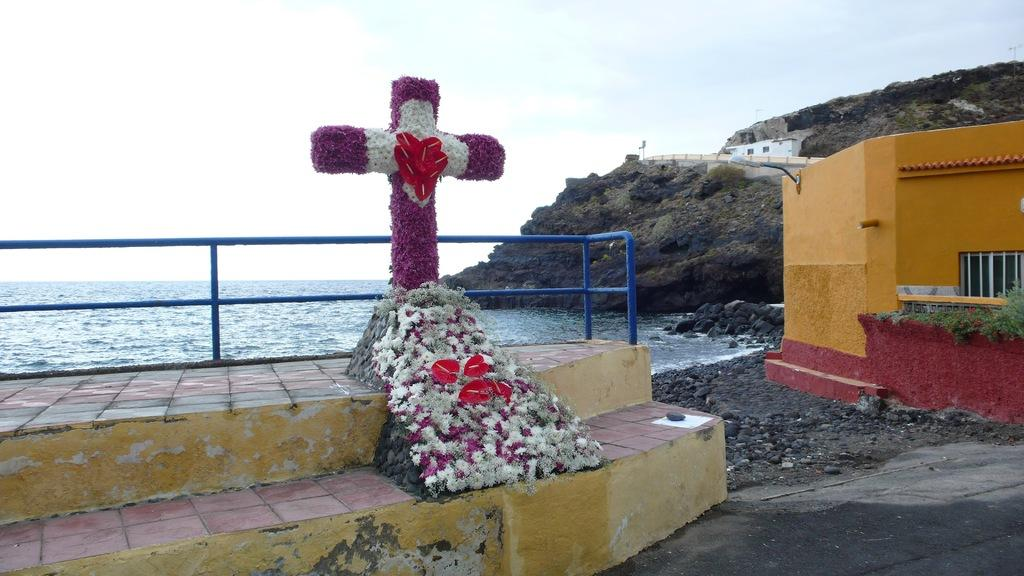What type of natural elements can be seen in the image? There are flowers, rocks, and plants visible in the image. What type of man-made structures are present in the image? There is a cross on steps, a fence, a road, and houses with windows in the image. What type of terrain is visible in the image? There are rocks and a road visible in the image. What is the condition of the sky in the image? The sky with clouds is visible in the background of the image. What type of water feature can be seen in the image? There is water visible in the image. What type of bone can be seen in the image? There is no bone present in the image. What type of thrill can be experienced by the plants in the image? Plants do not experience thrill, so this question is not applicable to the image. 